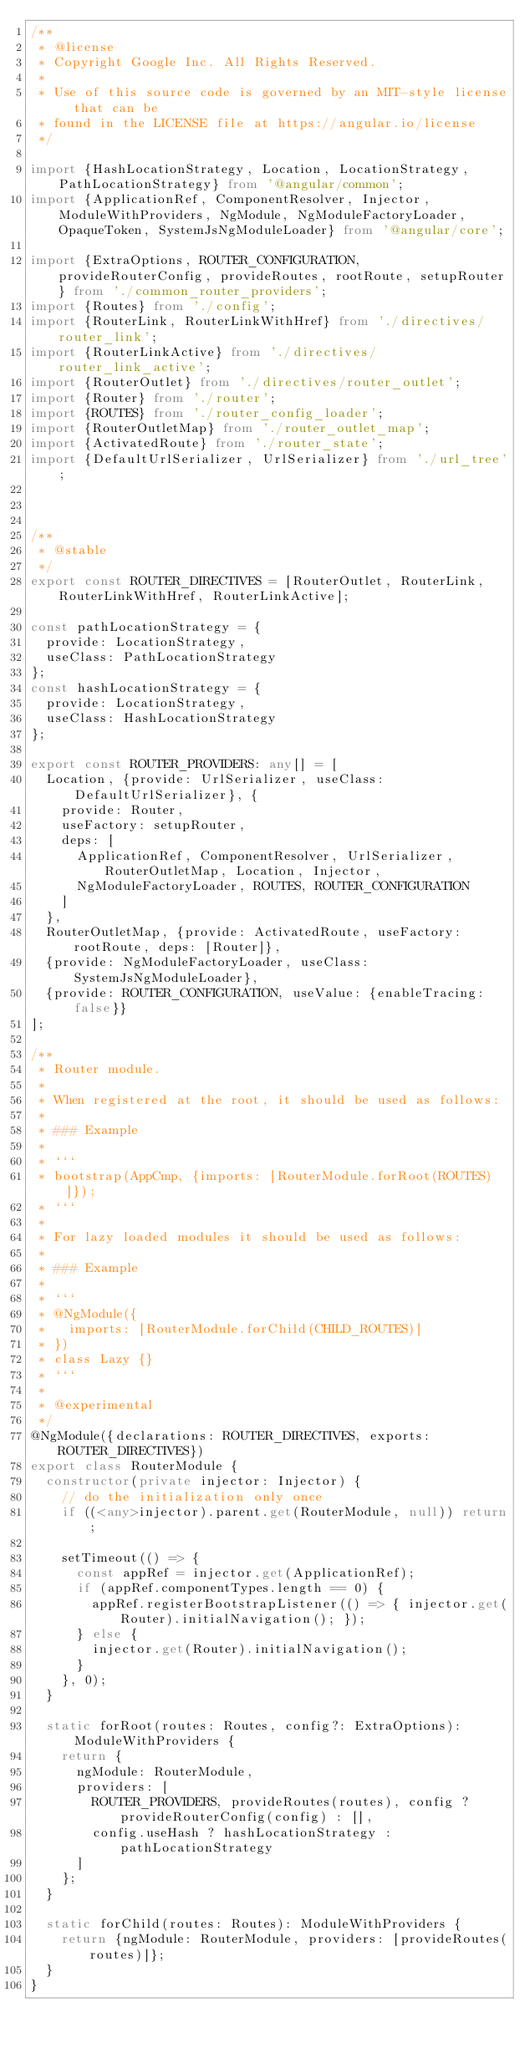<code> <loc_0><loc_0><loc_500><loc_500><_TypeScript_>/**
 * @license
 * Copyright Google Inc. All Rights Reserved.
 *
 * Use of this source code is governed by an MIT-style license that can be
 * found in the LICENSE file at https://angular.io/license
 */

import {HashLocationStrategy, Location, LocationStrategy, PathLocationStrategy} from '@angular/common';
import {ApplicationRef, ComponentResolver, Injector, ModuleWithProviders, NgModule, NgModuleFactoryLoader, OpaqueToken, SystemJsNgModuleLoader} from '@angular/core';

import {ExtraOptions, ROUTER_CONFIGURATION, provideRouterConfig, provideRoutes, rootRoute, setupRouter} from './common_router_providers';
import {Routes} from './config';
import {RouterLink, RouterLinkWithHref} from './directives/router_link';
import {RouterLinkActive} from './directives/router_link_active';
import {RouterOutlet} from './directives/router_outlet';
import {Router} from './router';
import {ROUTES} from './router_config_loader';
import {RouterOutletMap} from './router_outlet_map';
import {ActivatedRoute} from './router_state';
import {DefaultUrlSerializer, UrlSerializer} from './url_tree';



/**
 * @stable
 */
export const ROUTER_DIRECTIVES = [RouterOutlet, RouterLink, RouterLinkWithHref, RouterLinkActive];

const pathLocationStrategy = {
  provide: LocationStrategy,
  useClass: PathLocationStrategy
};
const hashLocationStrategy = {
  provide: LocationStrategy,
  useClass: HashLocationStrategy
};

export const ROUTER_PROVIDERS: any[] = [
  Location, {provide: UrlSerializer, useClass: DefaultUrlSerializer}, {
    provide: Router,
    useFactory: setupRouter,
    deps: [
      ApplicationRef, ComponentResolver, UrlSerializer, RouterOutletMap, Location, Injector,
      NgModuleFactoryLoader, ROUTES, ROUTER_CONFIGURATION
    ]
  },
  RouterOutletMap, {provide: ActivatedRoute, useFactory: rootRoute, deps: [Router]},
  {provide: NgModuleFactoryLoader, useClass: SystemJsNgModuleLoader},
  {provide: ROUTER_CONFIGURATION, useValue: {enableTracing: false}}
];

/**
 * Router module.
 *
 * When registered at the root, it should be used as follows:
 *
 * ### Example
 *
 * ```
 * bootstrap(AppCmp, {imports: [RouterModule.forRoot(ROUTES)]});
 * ```
 *
 * For lazy loaded modules it should be used as follows:
 *
 * ### Example
 *
 * ```
 * @NgModule({
 *   imports: [RouterModule.forChild(CHILD_ROUTES)]
 * })
 * class Lazy {}
 * ```
 *
 * @experimental
 */
@NgModule({declarations: ROUTER_DIRECTIVES, exports: ROUTER_DIRECTIVES})
export class RouterModule {
  constructor(private injector: Injector) {
    // do the initialization only once
    if ((<any>injector).parent.get(RouterModule, null)) return;

    setTimeout(() => {
      const appRef = injector.get(ApplicationRef);
      if (appRef.componentTypes.length == 0) {
        appRef.registerBootstrapListener(() => { injector.get(Router).initialNavigation(); });
      } else {
        injector.get(Router).initialNavigation();
      }
    }, 0);
  }

  static forRoot(routes: Routes, config?: ExtraOptions): ModuleWithProviders {
    return {
      ngModule: RouterModule,
      providers: [
        ROUTER_PROVIDERS, provideRoutes(routes), config ? provideRouterConfig(config) : [],
        config.useHash ? hashLocationStrategy : pathLocationStrategy
      ]
    };
  }

  static forChild(routes: Routes): ModuleWithProviders {
    return {ngModule: RouterModule, providers: [provideRoutes(routes)]};
  }
}
</code> 